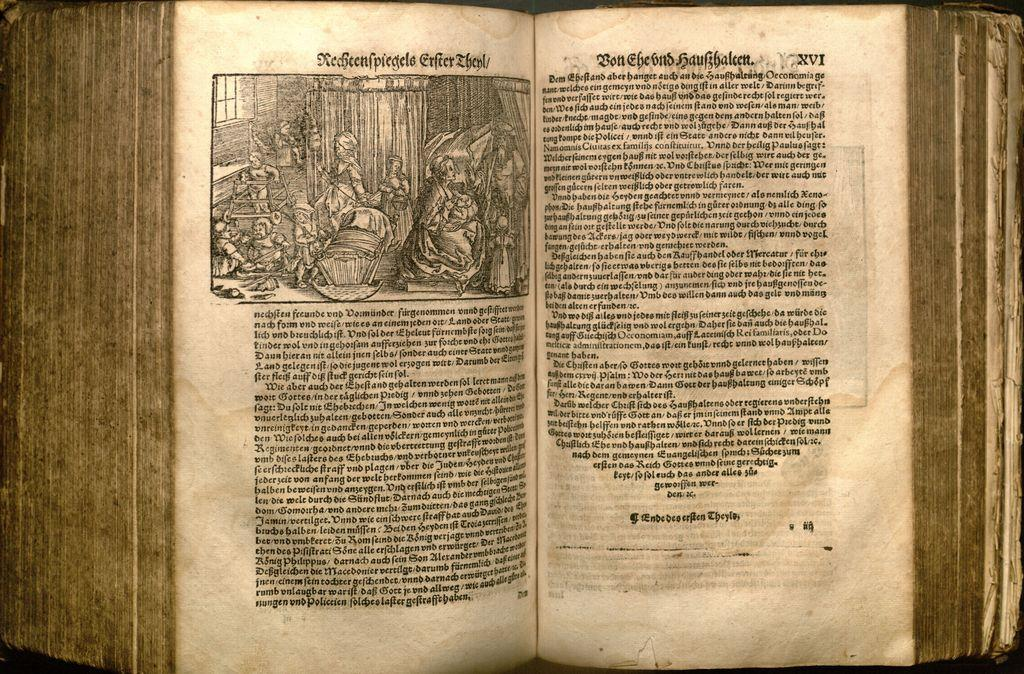<image>
Share a concise interpretation of the image provided. An old book with a lithograph is open to page XVI. 